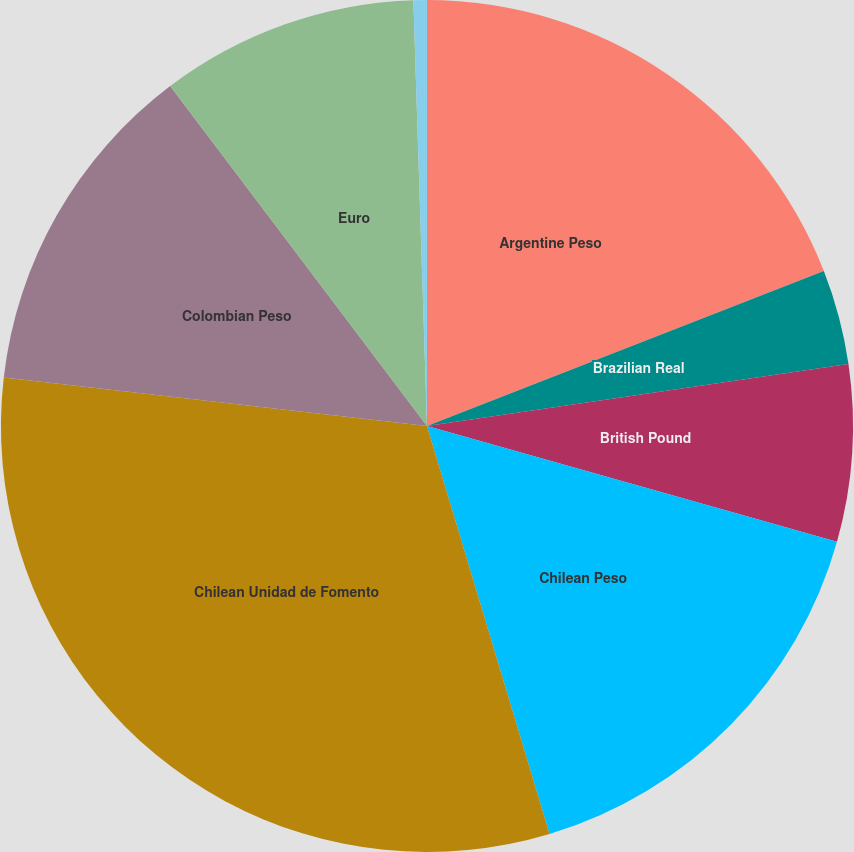Convert chart to OTSL. <chart><loc_0><loc_0><loc_500><loc_500><pie_chart><fcel>Argentine Peso<fcel>Brazilian Real<fcel>British Pound<fcel>Chilean Peso<fcel>Chilean Unidad de Fomento<fcel>Colombian Peso<fcel>Euro<fcel>Kazakhstani Tenge<nl><fcel>19.08%<fcel>3.6%<fcel>6.7%<fcel>15.98%<fcel>31.46%<fcel>12.89%<fcel>9.79%<fcel>0.51%<nl></chart> 